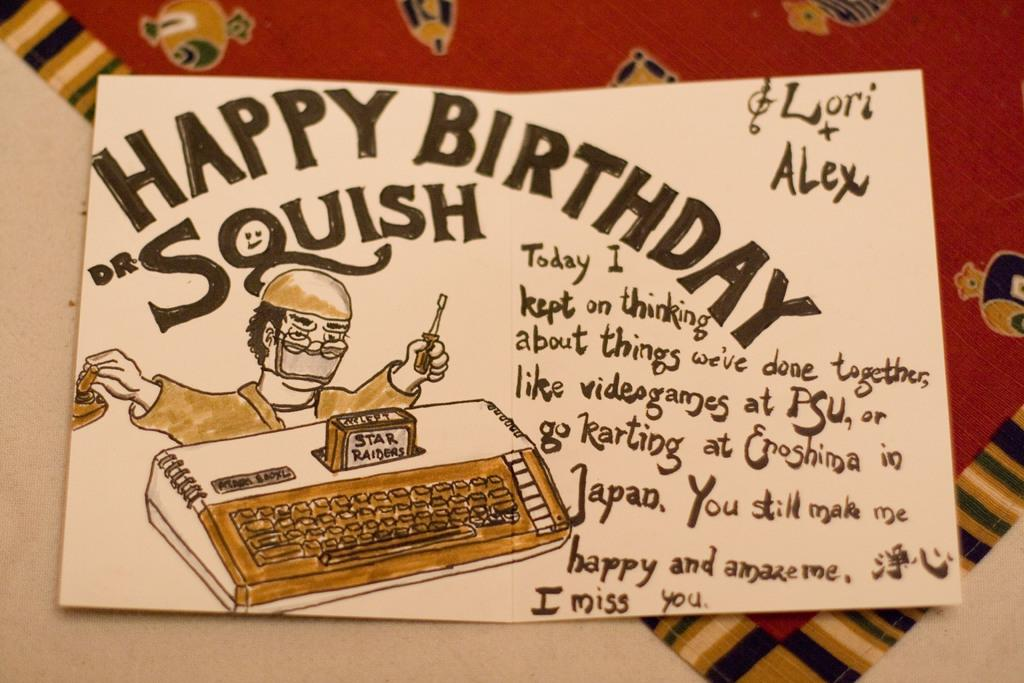Provide a one-sentence caption for the provided image. A handmade card reading Happy Birthday Squish on it. 